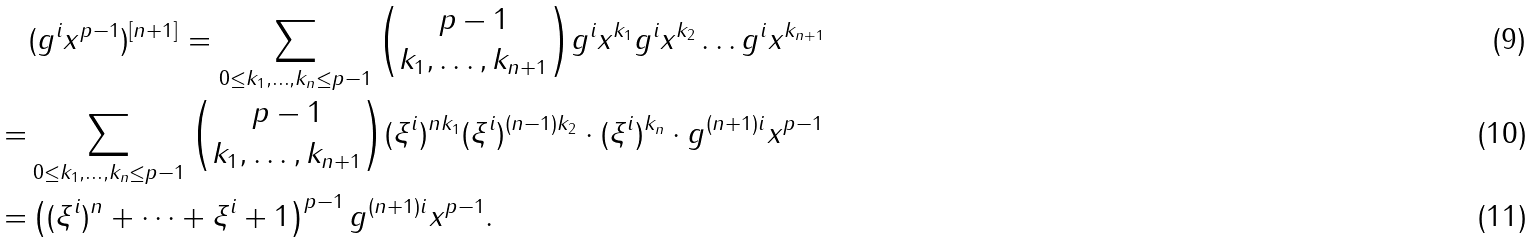Convert formula to latex. <formula><loc_0><loc_0><loc_500><loc_500>& ( g ^ { i } x ^ { p - 1 } ) ^ { [ n + 1 ] } = \sum _ { \substack { 0 \leq k _ { 1 } , \dots , k _ { n } \leq p - 1 } } { p - 1 \choose k _ { 1 } , \dots , k _ { n + 1 } } g ^ { i } x ^ { k _ { 1 } } g ^ { i } x ^ { k _ { 2 } } \dots g ^ { i } x ^ { k _ { n + 1 } } \\ = & \sum _ { \substack { 0 \leq k _ { 1 } , \dots , k _ { n } \leq p - 1 } } { p - 1 \choose k _ { 1 } , \dots , k _ { n + 1 } } ( \xi ^ { i } ) ^ { n k _ { 1 } } ( \xi ^ { i } ) ^ { ( n - 1 ) k _ { 2 } } \cdot ( \xi ^ { i } ) ^ { k _ { n } } \cdot g ^ { ( n + 1 ) i } x ^ { p - 1 } \\ = & \left ( ( \xi ^ { i } ) ^ { n } + \cdots + \xi ^ { i } + 1 \right ) ^ { p - 1 } g ^ { ( n + 1 ) i } x ^ { p - 1 } .</formula> 